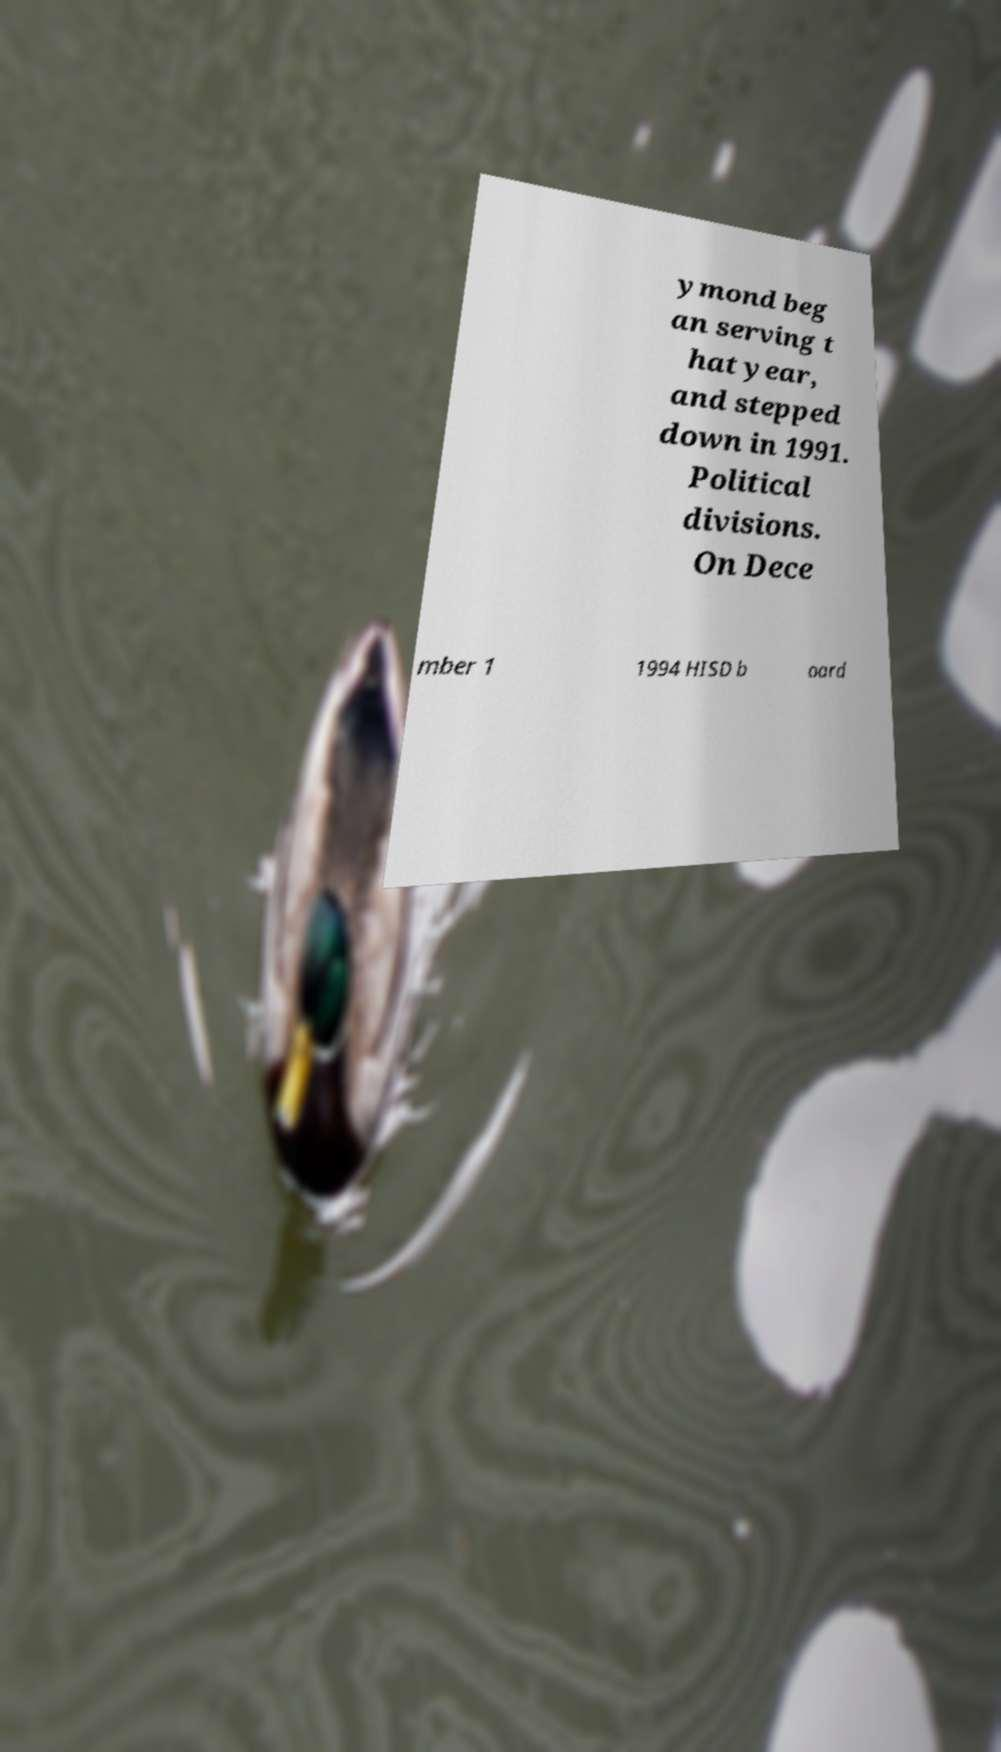Could you extract and type out the text from this image? ymond beg an serving t hat year, and stepped down in 1991. Political divisions. On Dece mber 1 1994 HISD b oard 